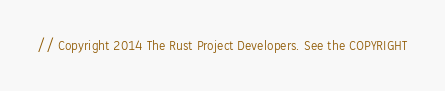Convert code to text. <code><loc_0><loc_0><loc_500><loc_500><_Rust_>// Copyright 2014 The Rust Project Developers. See the COPYRIGHT</code> 